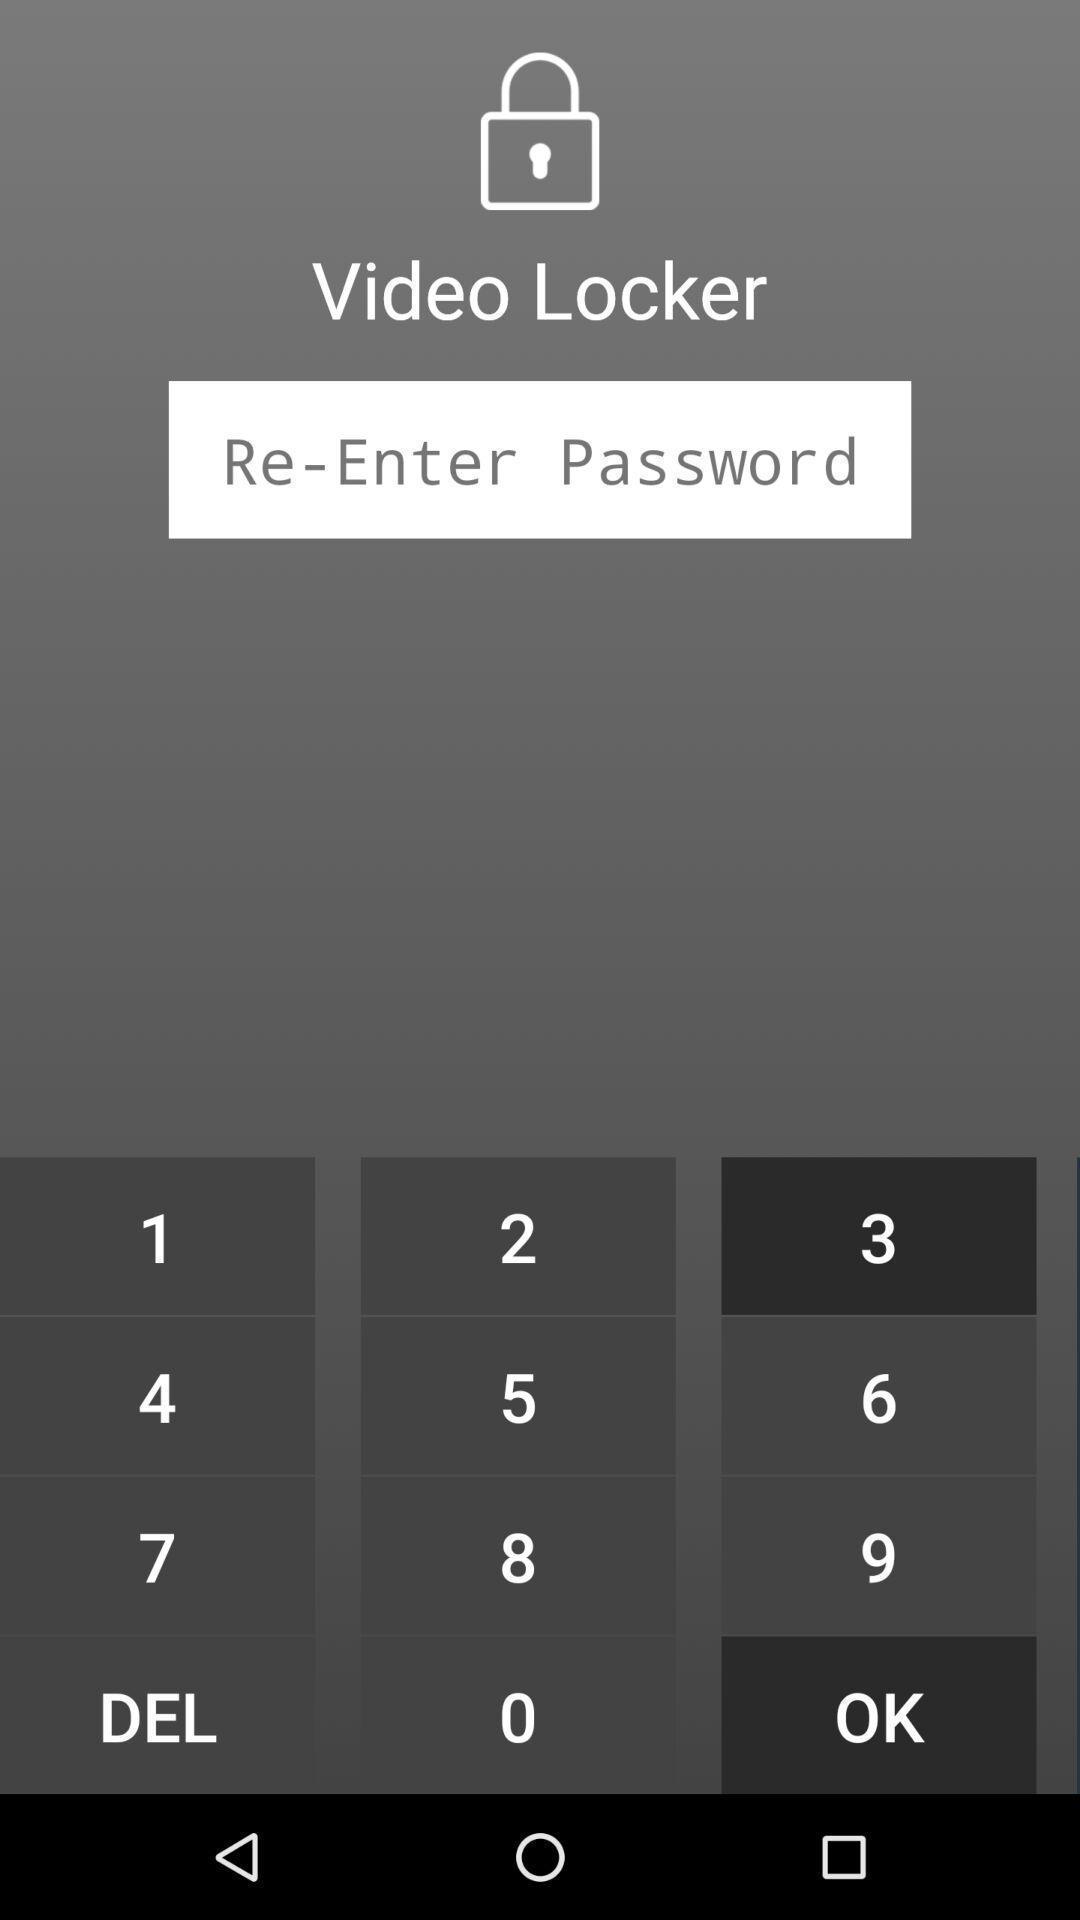Please provide a description for this image. Screen shows lock page of videos hiding app. 